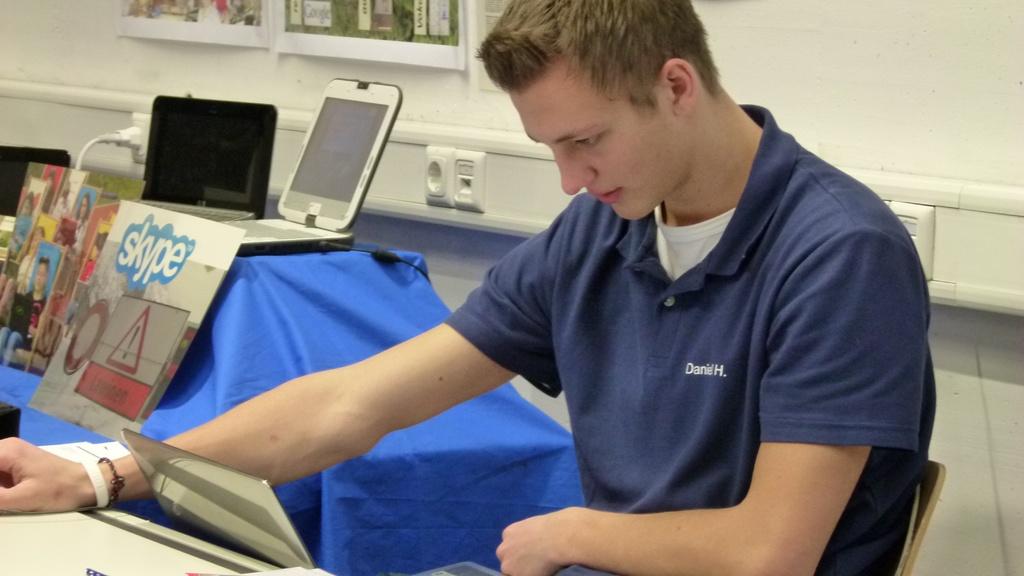What application is featured on the left poster?
Ensure brevity in your answer.  Skype. 